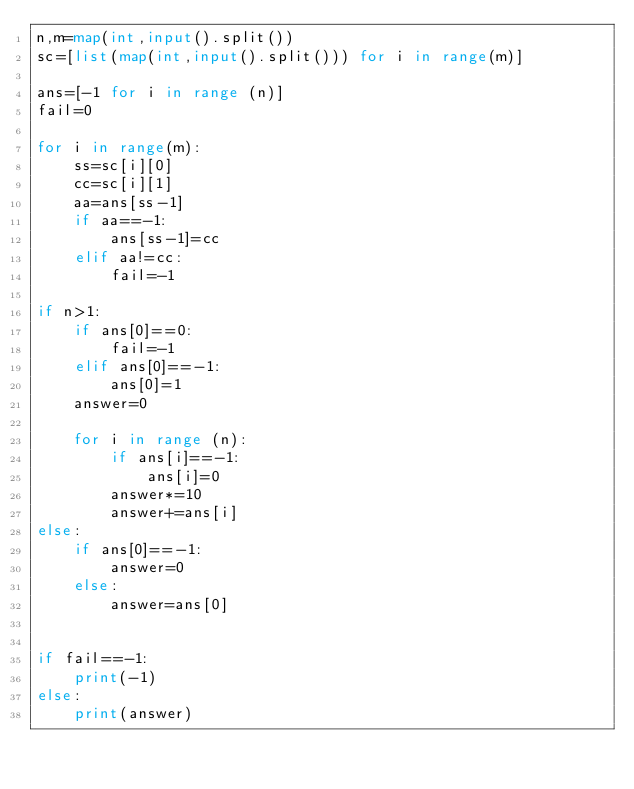<code> <loc_0><loc_0><loc_500><loc_500><_Python_>n,m=map(int,input().split())
sc=[list(map(int,input().split())) for i in range(m)]

ans=[-1 for i in range (n)]
fail=0

for i in range(m):
    ss=sc[i][0]
    cc=sc[i][1]
    aa=ans[ss-1]
    if aa==-1:
        ans[ss-1]=cc
    elif aa!=cc:
        fail=-1

if n>1:
    if ans[0]==0:
        fail=-1
    elif ans[0]==-1:
        ans[0]=1
    answer=0
    
    for i in range (n):
        if ans[i]==-1:
            ans[i]=0
        answer*=10
        answer+=ans[i]
else:
    if ans[0]==-1:
        answer=0
    else:
        answer=ans[0]
    

if fail==-1:
    print(-1)
else:
    print(answer)
    </code> 